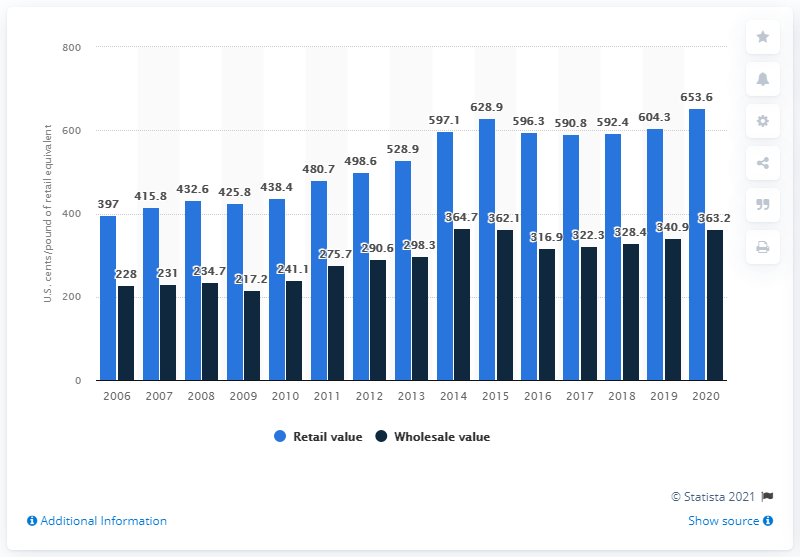Give some essential details in this illustration. In 2020, the average value of wholesale beef per pound of retail equivalent in the United States was 363.2 